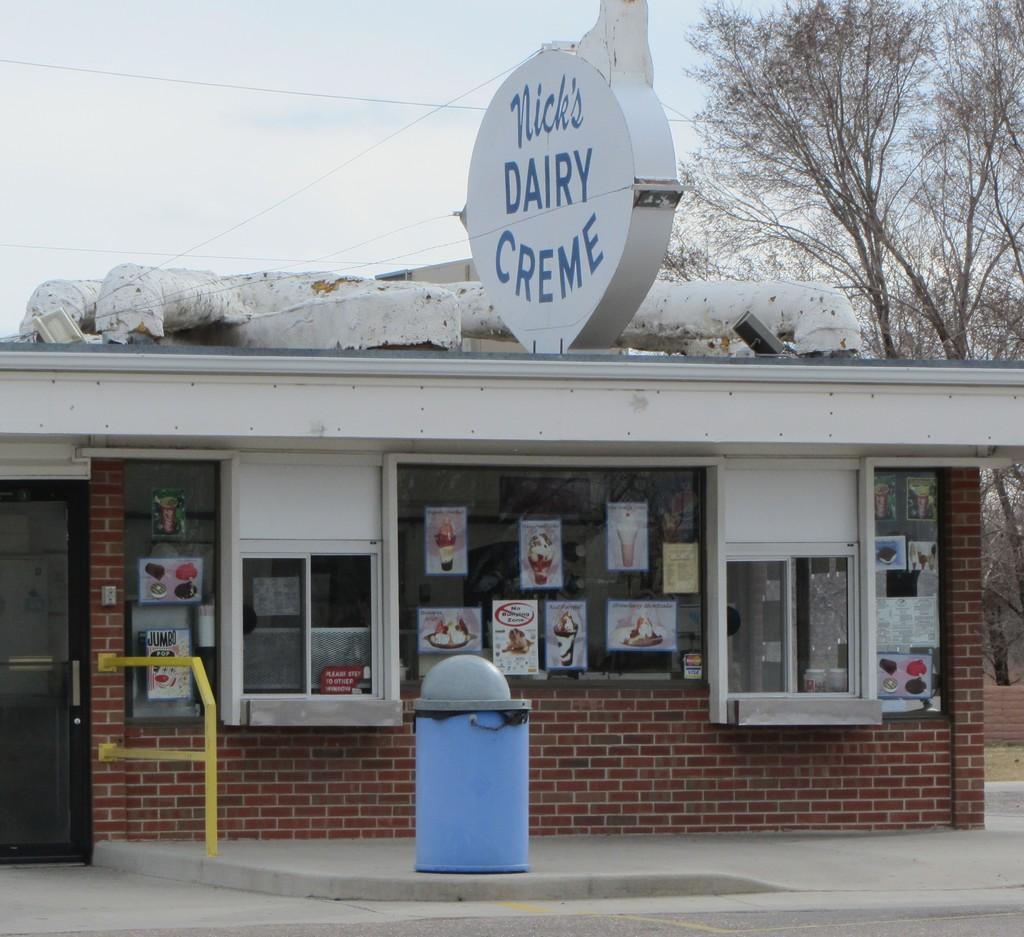Please provide a concise description of this image. In this image we can see a building, on the building, we can see some posters and a board with text, there are some trees, wires, windows and doors, in the background, we can see the sky, in front of the building we can see an object. 